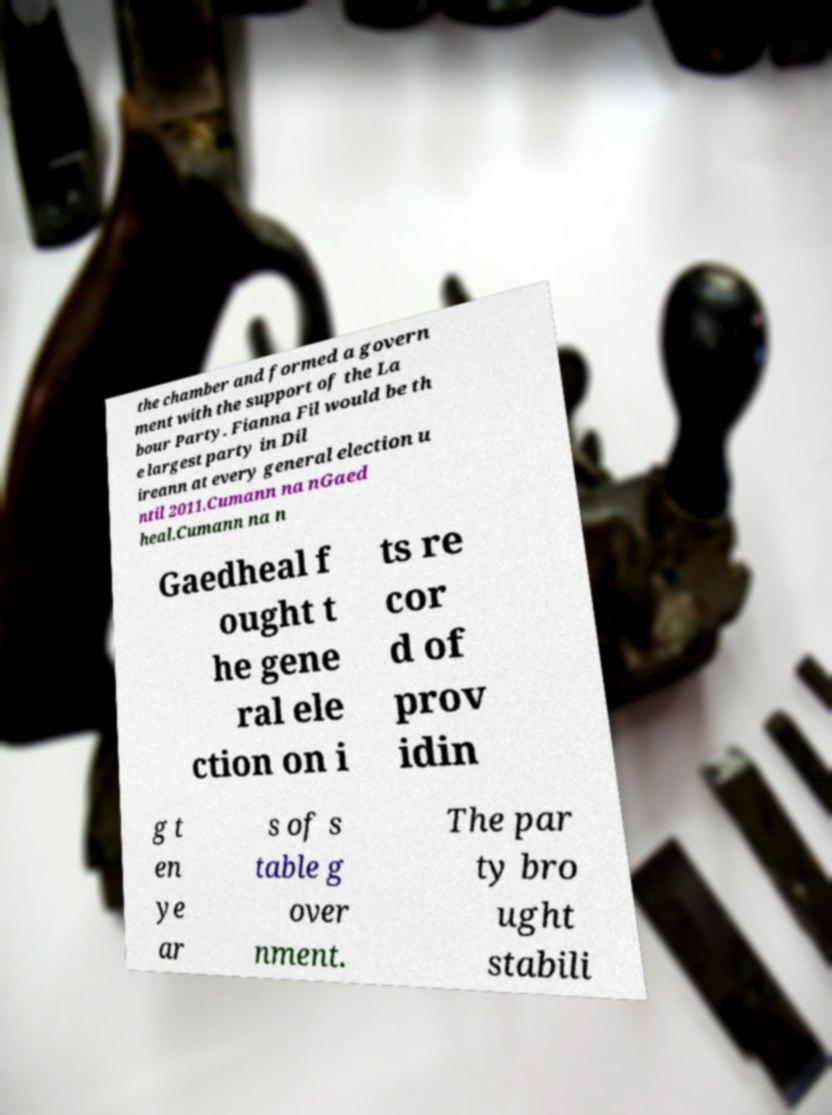Please read and relay the text visible in this image. What does it say? the chamber and formed a govern ment with the support of the La bour Party. Fianna Fil would be th e largest party in Dil ireann at every general election u ntil 2011.Cumann na nGaed heal.Cumann na n Gaedheal f ought t he gene ral ele ction on i ts re cor d of prov idin g t en ye ar s of s table g over nment. The par ty bro ught stabili 